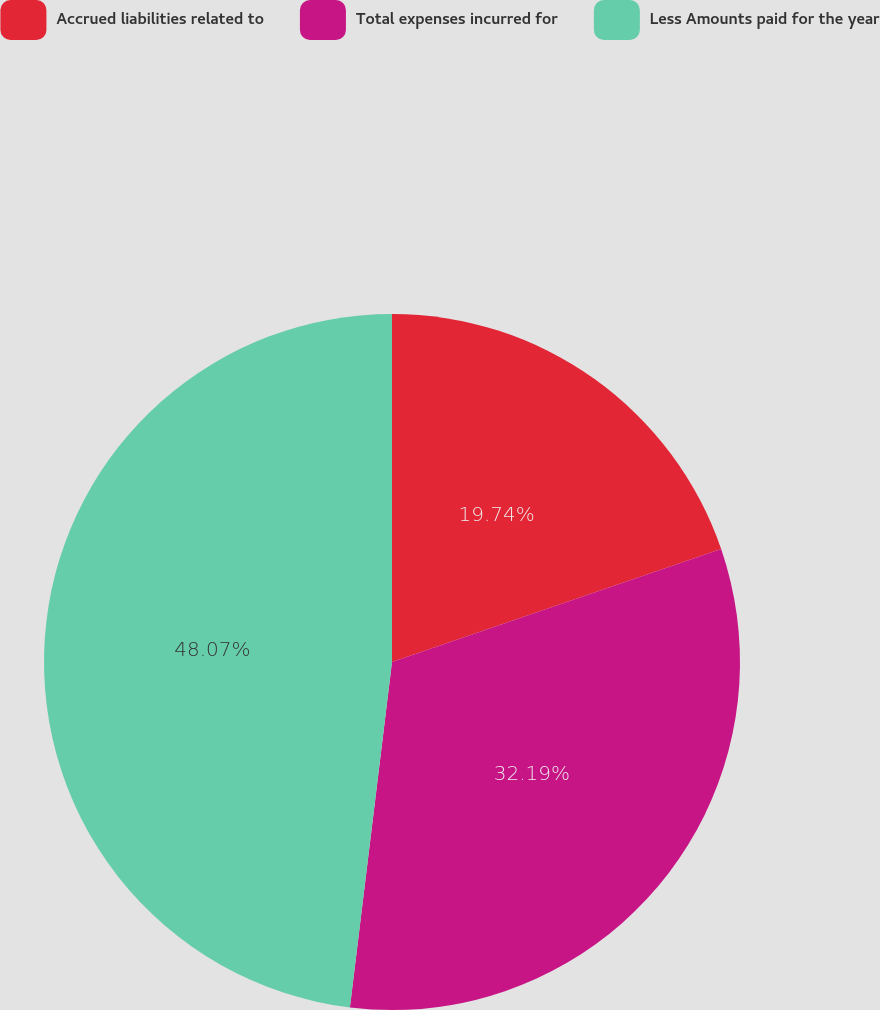<chart> <loc_0><loc_0><loc_500><loc_500><pie_chart><fcel>Accrued liabilities related to<fcel>Total expenses incurred for<fcel>Less Amounts paid for the year<nl><fcel>19.74%<fcel>32.19%<fcel>48.07%<nl></chart> 